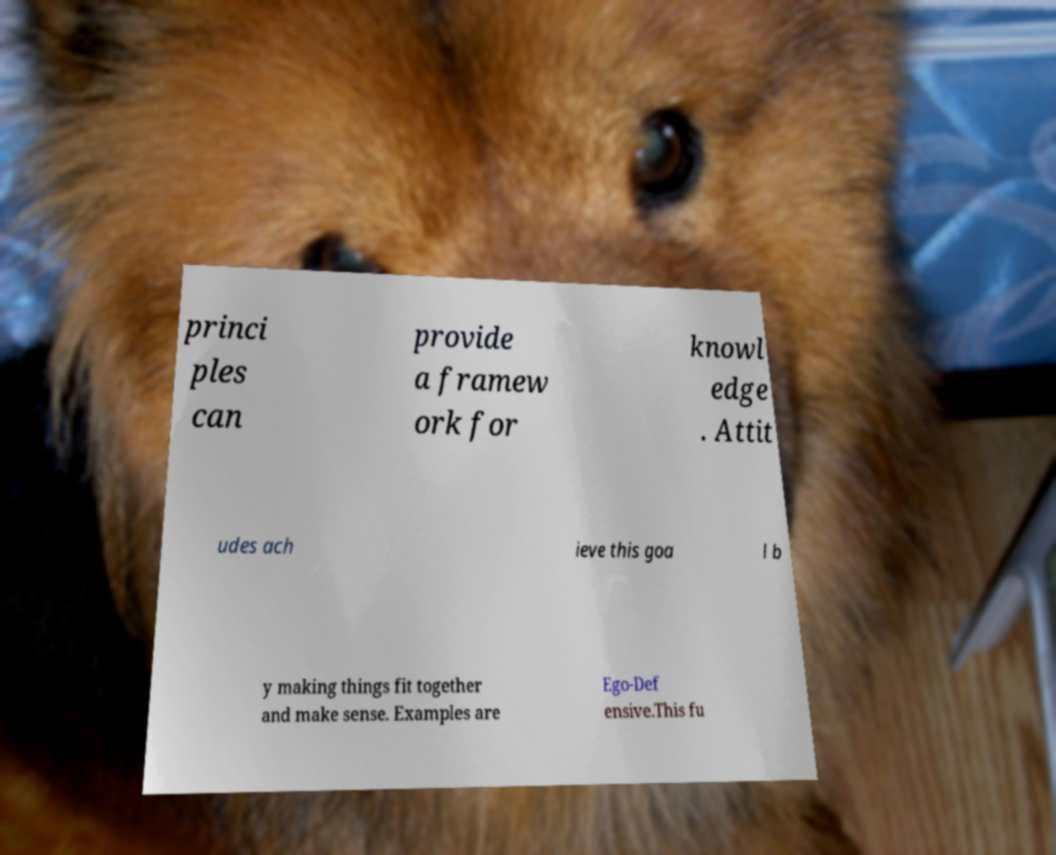There's text embedded in this image that I need extracted. Can you transcribe it verbatim? princi ples can provide a framew ork for knowl edge . Attit udes ach ieve this goa l b y making things fit together and make sense. Examples are Ego-Def ensive.This fu 